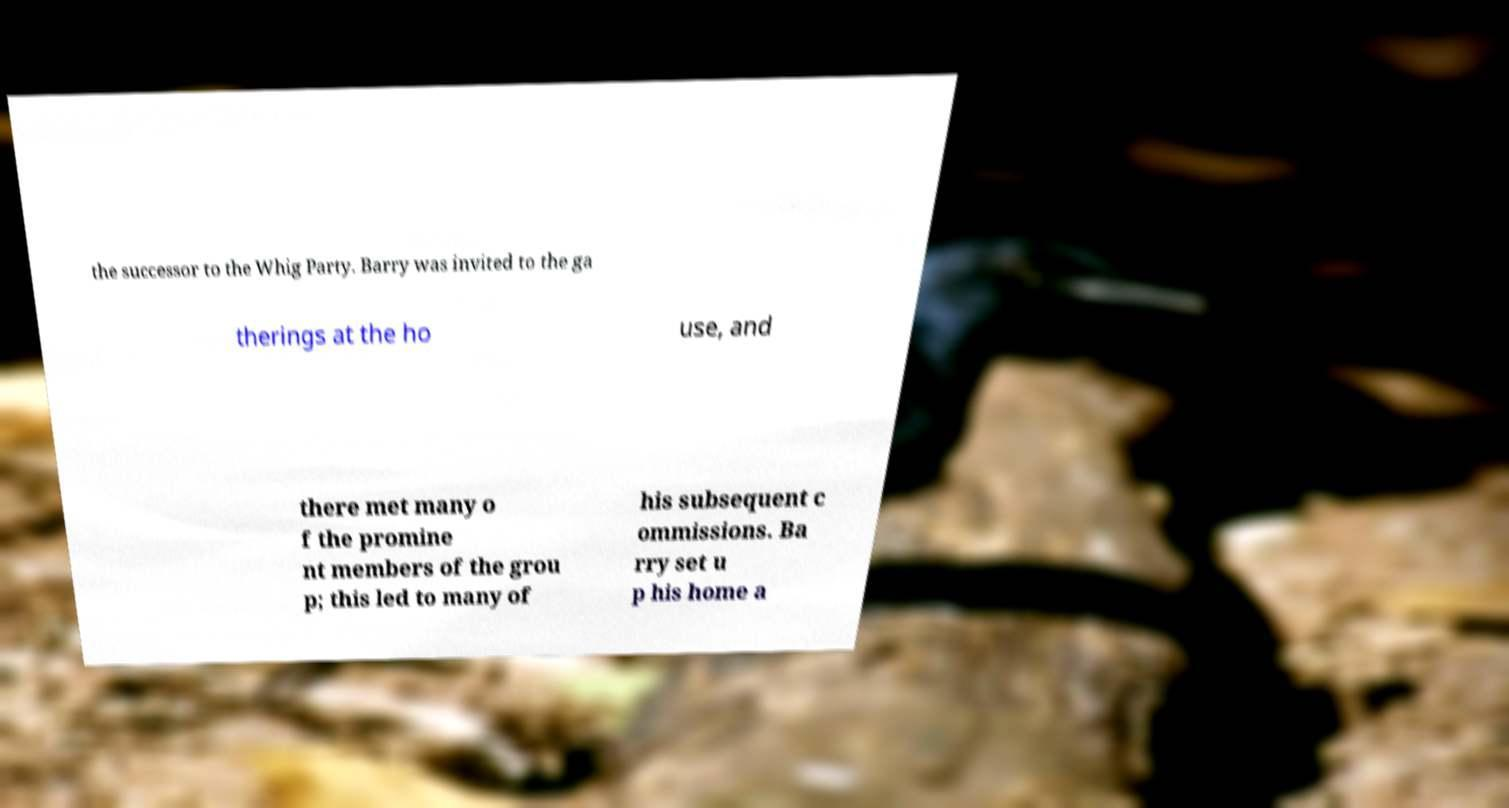Could you assist in decoding the text presented in this image and type it out clearly? the successor to the Whig Party. Barry was invited to the ga therings at the ho use, and there met many o f the promine nt members of the grou p; this led to many of his subsequent c ommissions. Ba rry set u p his home a 